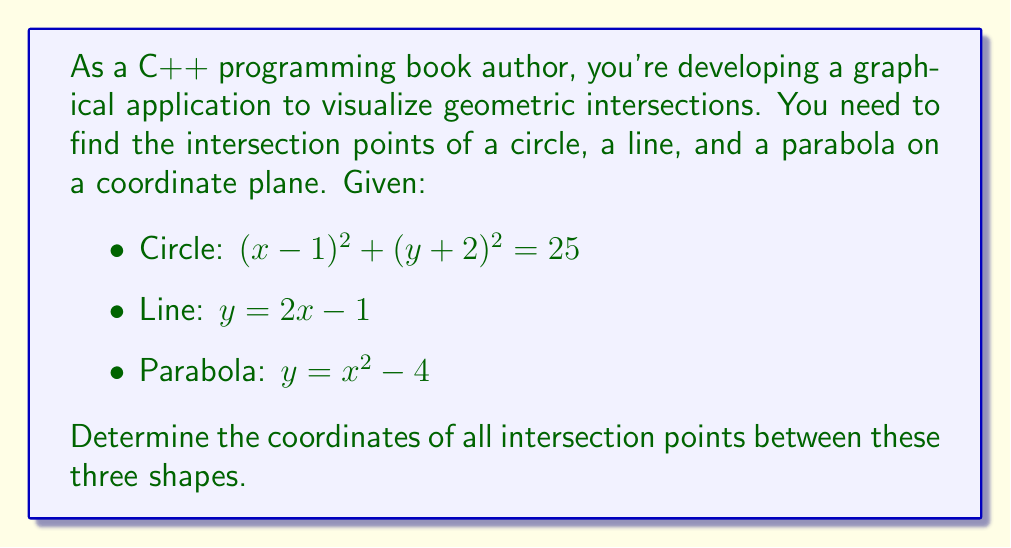Help me with this question. Let's approach this step-by-step:

1) First, let's find the intersections of the circle and the line:

   Substitute the line equation into the circle equation:
   $$(x-1)^2 + ((2x-1)+2)^2 = 25$$
   $$(x-1)^2 + (2x+1)^2 = 25$$
   $$x^2 - 2x + 1 + 4x^2 + 4x + 1 = 25$$
   $$5x^2 + 2x - 23 = 0$$

   Solve this quadratic equation:
   $$x = \frac{-2 \pm \sqrt{4 + 4(5)(23)}}{2(5)} = \frac{-2 \pm \sqrt{464}}{10} = \frac{-2 \pm 21.54}{10}$$
   $$x_1 \approx 1.954, x_2 \approx -0.754$$

   Substitute these x-values back into the line equation:
   $$y_1 \approx 2(1.954) - 1 \approx 2.908$$
   $$y_2 \approx 2(-0.754) - 1 \approx -2.508$$

   Circle-Line intersection points: $$(1.954, 2.908)$$ and $$(-0.754, -2.508)$$

2) Now, let's find the intersections of the circle and the parabola:

   Substitute the parabola equation into the circle equation:
   $$(x-1)^2 + ((x^2-4)+2)^2 = 25$$
   $$(x-1)^2 + (x^2-2)^2 = 25$$
   $$x^2 - 2x + 1 + x^4 - 4x^2 + 4 = 25$$
   $$x^4 - 3x^2 - 2x - 20 = 0$$

   This is a 4th degree equation. It can be solved numerically or by factoring.
   The solutions are approximately: $$x \approx -2.236, -1.414, 1.414, 2.236$$

   Substitute these x-values into the parabola equation:
   $$y \approx 1, 2, -2, 1$$ respectively

   Circle-Parabola intersection points: $$(-2.236, 1)$$, $$(-1.414, 2)$$, $$(1.414, -2)$$, $$(2.236, 1)$$

3) Finally, let's find the intersections of the line and the parabola:

   Equate the line and parabola equations:
   $$2x - 1 = x^2 - 4$$
   $$x^2 - 2x - 3 = 0$$

   Solve this quadratic equation:
   $$x = \frac{2 \pm \sqrt{4 + 4(3)}}{2} = \frac{2 \pm \sqrt{16}}{2} = 1 \pm 2$$
   $$x_1 = 3, x_2 = -1$$

   Substitute these x-values back into either equation:
   $$y_1 = 2(3) - 1 = 5$$
   $$y_2 = 2(-1) - 1 = -3$$

   Line-Parabola intersection points: $$(3, 5)$$ and $$(-1, -3)$$

Therefore, all unique intersection points are:
$$(1.954, 2.908)$$, $$(-0.754, -2.508)$$, $$(-2.236, 1)$$, $$(-1.414, 2)$$, $$(1.414, -2)$$, $$(2.236, 1)$$, $$(3, 5)$$, $$(-1, -3)$$
Answer: $$(1.954, 2.908)$$, $$(-0.754, -2.508)$$, $$(-2.236, 1)$$, $$(-1.414, 2)$$, $$(1.414, -2)$$, $$(2.236, 1)$$, $$(3, 5)$$, $$(-1, -3)$$ 